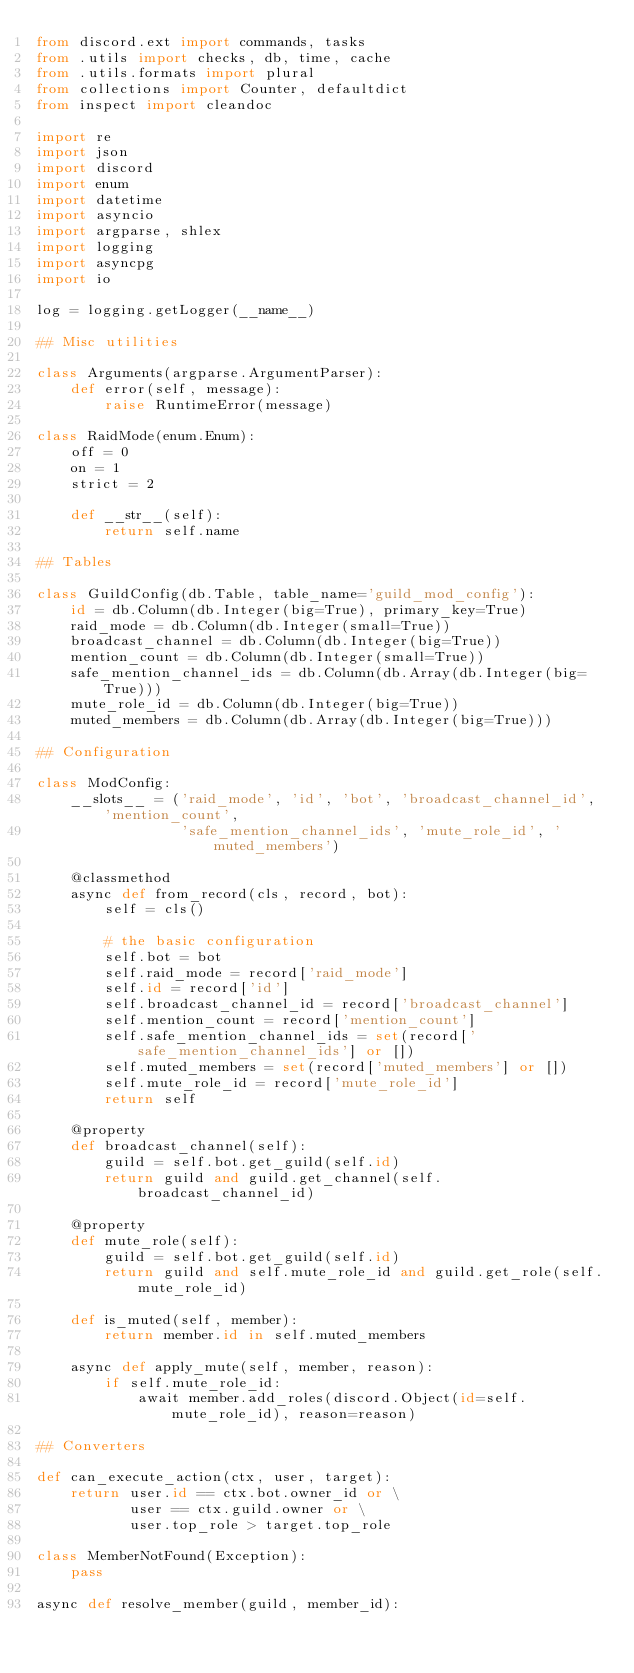Convert code to text. <code><loc_0><loc_0><loc_500><loc_500><_Python_>from discord.ext import commands, tasks
from .utils import checks, db, time, cache
from .utils.formats import plural
from collections import Counter, defaultdict
from inspect import cleandoc

import re
import json
import discord
import enum
import datetime
import asyncio
import argparse, shlex
import logging
import asyncpg
import io

log = logging.getLogger(__name__)

## Misc utilities

class Arguments(argparse.ArgumentParser):
    def error(self, message):
        raise RuntimeError(message)

class RaidMode(enum.Enum):
    off = 0
    on = 1
    strict = 2

    def __str__(self):
        return self.name

## Tables

class GuildConfig(db.Table, table_name='guild_mod_config'):
    id = db.Column(db.Integer(big=True), primary_key=True)
    raid_mode = db.Column(db.Integer(small=True))
    broadcast_channel = db.Column(db.Integer(big=True))
    mention_count = db.Column(db.Integer(small=True))
    safe_mention_channel_ids = db.Column(db.Array(db.Integer(big=True)))
    mute_role_id = db.Column(db.Integer(big=True))
    muted_members = db.Column(db.Array(db.Integer(big=True)))

## Configuration

class ModConfig:
    __slots__ = ('raid_mode', 'id', 'bot', 'broadcast_channel_id', 'mention_count',
                 'safe_mention_channel_ids', 'mute_role_id', 'muted_members')

    @classmethod
    async def from_record(cls, record, bot):
        self = cls()

        # the basic configuration
        self.bot = bot
        self.raid_mode = record['raid_mode']
        self.id = record['id']
        self.broadcast_channel_id = record['broadcast_channel']
        self.mention_count = record['mention_count']
        self.safe_mention_channel_ids = set(record['safe_mention_channel_ids'] or [])
        self.muted_members = set(record['muted_members'] or [])
        self.mute_role_id = record['mute_role_id']
        return self

    @property
    def broadcast_channel(self):
        guild = self.bot.get_guild(self.id)
        return guild and guild.get_channel(self.broadcast_channel_id)

    @property
    def mute_role(self):
        guild = self.bot.get_guild(self.id)
        return guild and self.mute_role_id and guild.get_role(self.mute_role_id)

    def is_muted(self, member):
        return member.id in self.muted_members

    async def apply_mute(self, member, reason):
        if self.mute_role_id:
            await member.add_roles(discord.Object(id=self.mute_role_id), reason=reason)

## Converters

def can_execute_action(ctx, user, target):
    return user.id == ctx.bot.owner_id or \
           user == ctx.guild.owner or \
           user.top_role > target.top_role

class MemberNotFound(Exception):
    pass

async def resolve_member(guild, member_id):</code> 